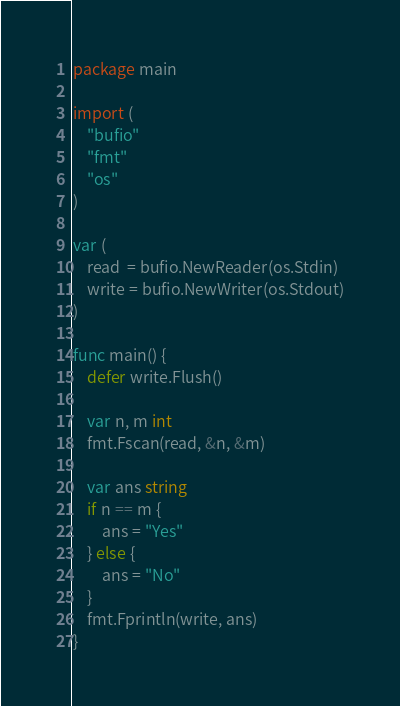<code> <loc_0><loc_0><loc_500><loc_500><_Go_>package main

import (
	"bufio"
	"fmt"
	"os"
)

var (
	read  = bufio.NewReader(os.Stdin)
	write = bufio.NewWriter(os.Stdout)
)

func main() {
	defer write.Flush()

	var n, m int
	fmt.Fscan(read, &n, &m)

	var ans string
	if n == m {
		ans = "Yes"
	} else {
		ans = "No"
	}
	fmt.Fprintln(write, ans)
}
</code> 